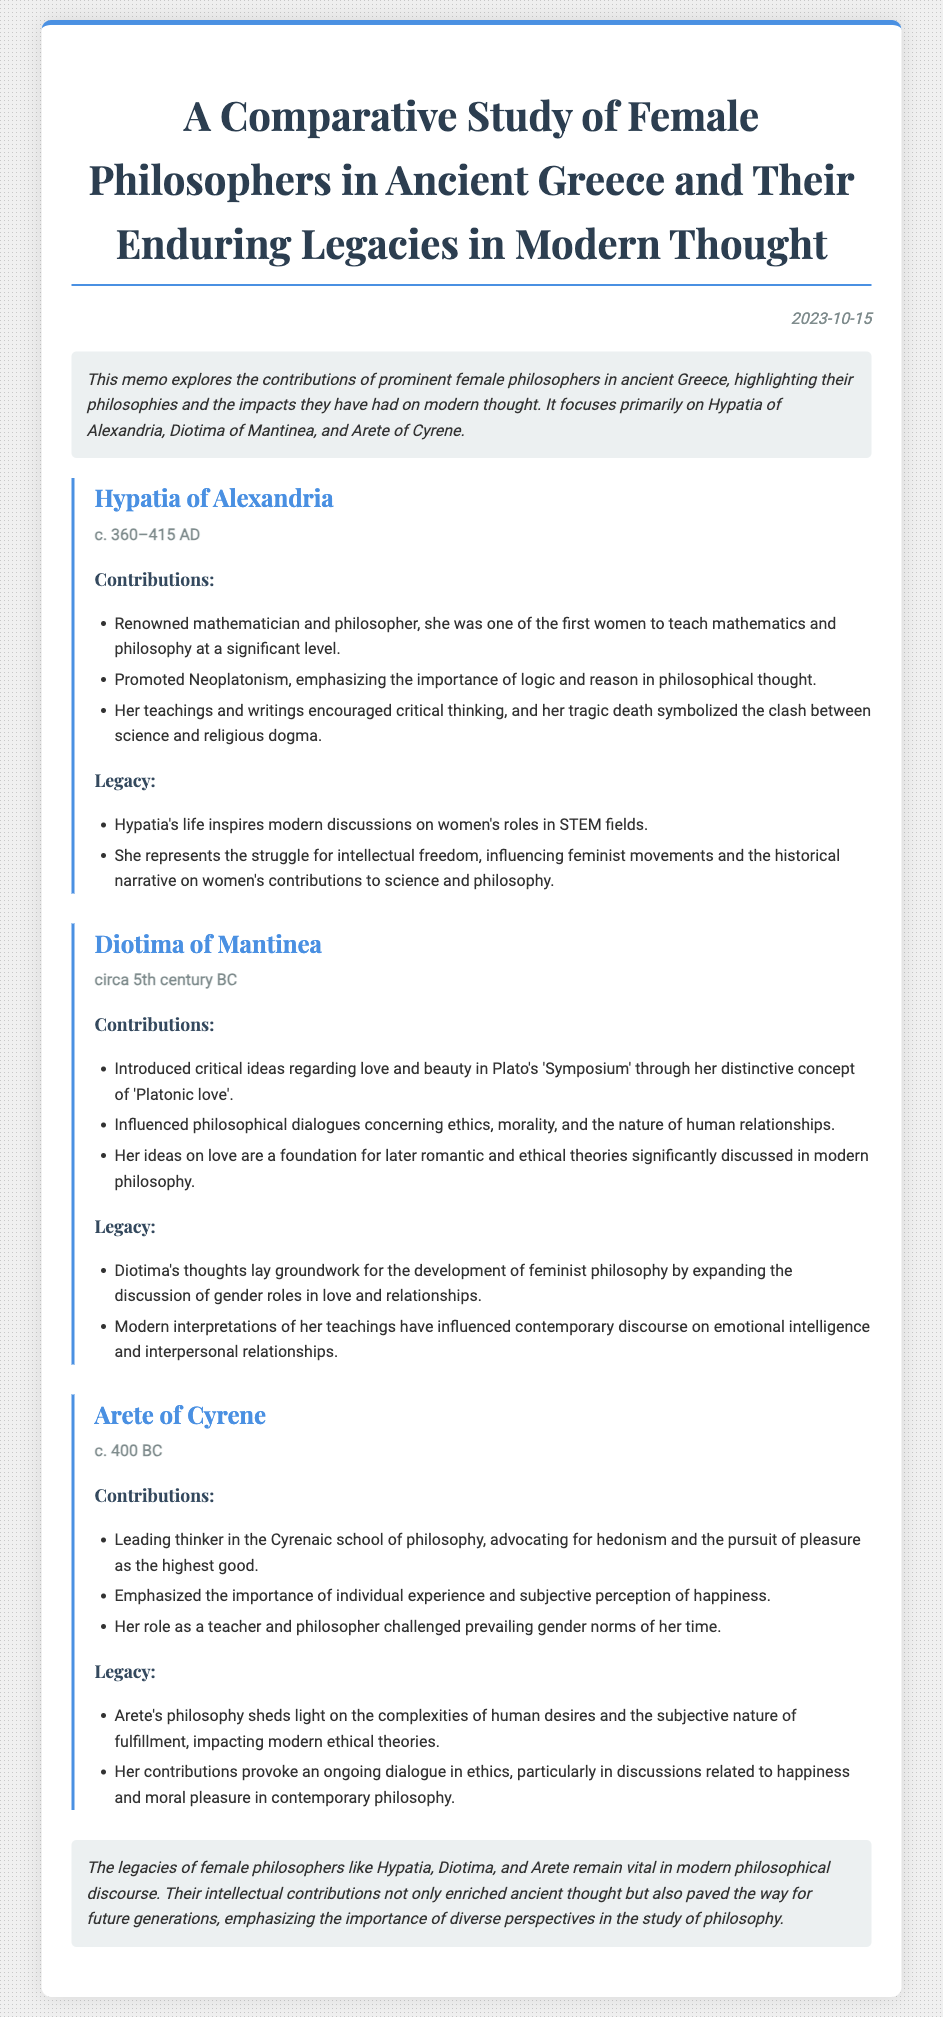What is the main focus of the memo? The memo primarily explores contributions of female philosophers in ancient Greece and their impacts on modern thought.
Answer: Contributions of female philosophers in ancient Greece and their impacts on modern thought Who is highlighted as a prominent philosopher from Alexandria? The document specifically mentions Hypatia of Alexandria as a prominent philosopher.
Answer: Hypatia of Alexandria In what century did Diotima of Mantinea live? The lifespan of Diotima of Mantinea is noted as circa 5th century BC.
Answer: 5th century BC What philosophical concept did Diotima introduce in Plato's 'Symposium'? Diotima is recognized for introducing the concept of 'Platonic love' in Plato's 'Symposium'.
Answer: 'Platonic love' What was Arete of Cyrene's main philosophical stance? Arete of Cyrene was a leading thinker in the Cyrenaic school of philosophy, advocating for hedonism.
Answer: Hedonism What significant event is symbolized by Hypatia's tragic death? Her tragic death symbolizes the clash between science and religious dogma.
Answer: Clash between science and religious dogma What impact did Diotima's ideas have on modern philosophy? Diotima's ideas are a foundation for later romantic and ethical theories significantly discussed in modern philosophy.
Answer: Foundation for later romantic and ethical theories What theme do Hypatia and Arete's legacies emphasize? Both philosophers' legacies emphasize the importance of diverse perspectives in the study of philosophy.
Answer: Importance of diverse perspectives in philosophy 